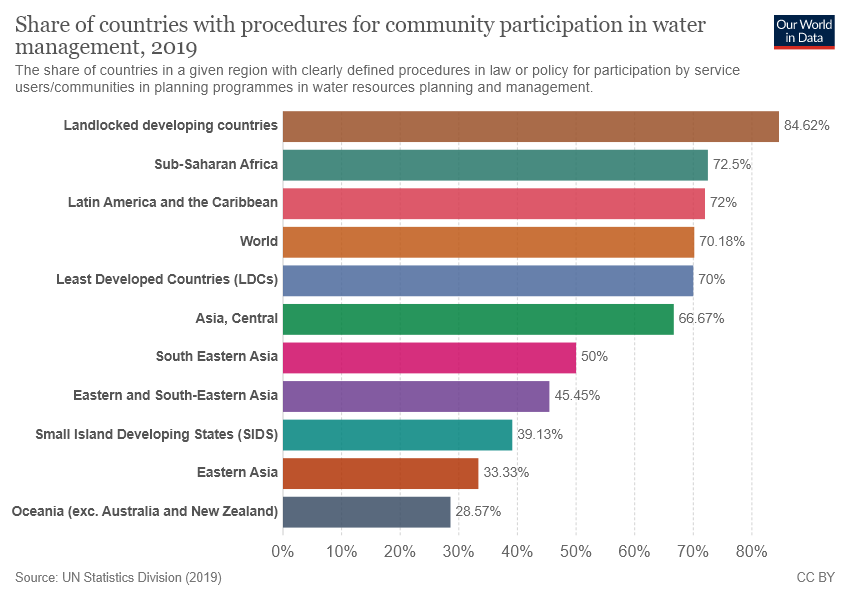List a handful of essential elements in this visual. The median value of all bars is greater than 60. The value for Asia and Central is 0.6667... 